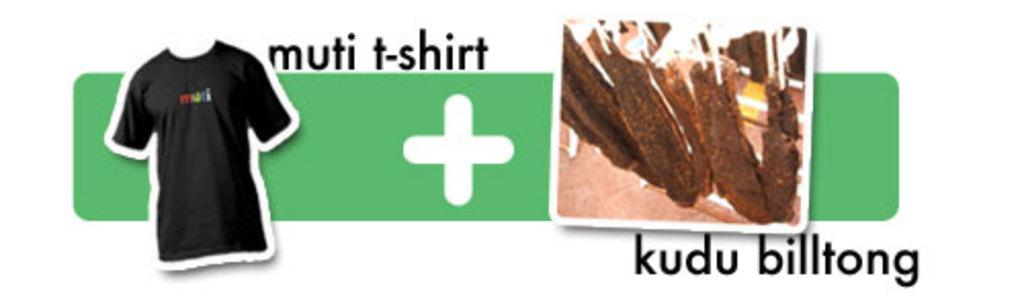<image>
Summarize the visual content of the image. A black Multi branded t-shirt next to a kudo biltong. 